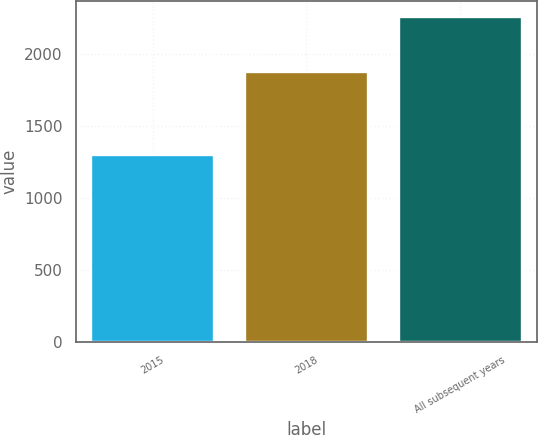Convert chart to OTSL. <chart><loc_0><loc_0><loc_500><loc_500><bar_chart><fcel>2015<fcel>2018<fcel>All subsequent years<nl><fcel>1296<fcel>1871<fcel>2255<nl></chart> 